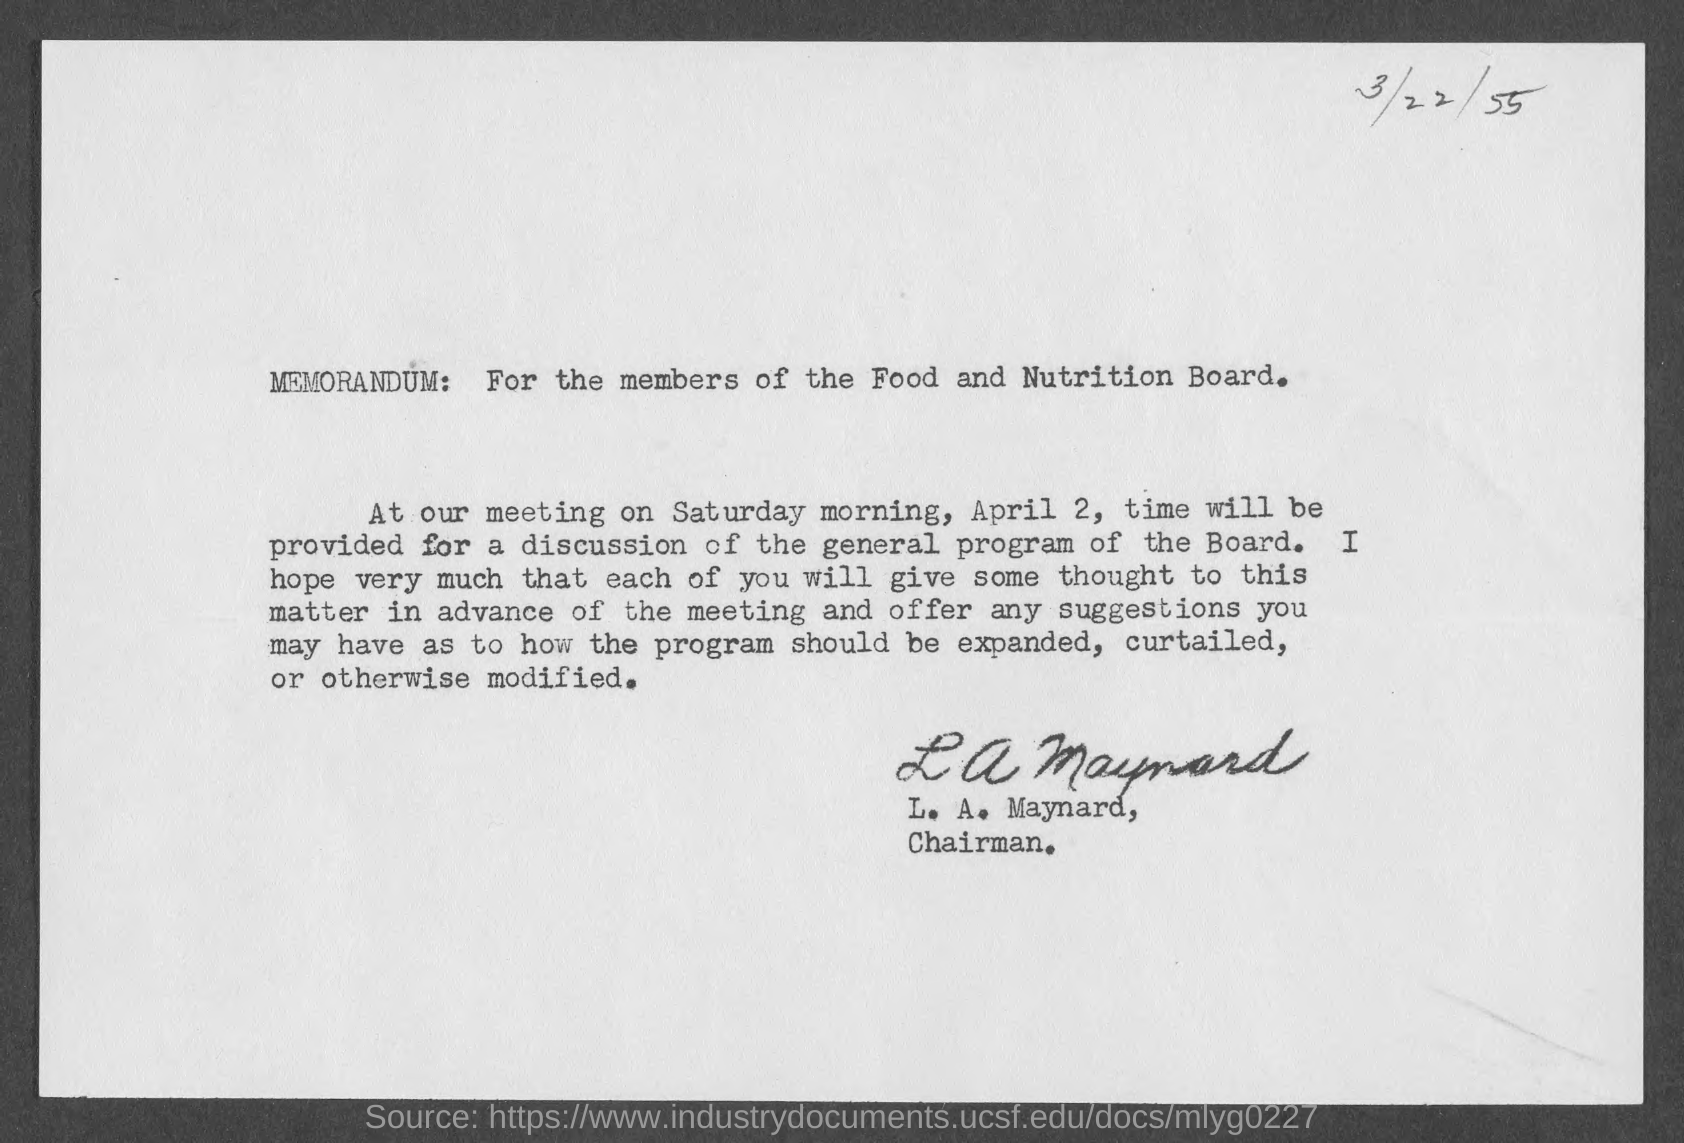When is the document dated?
Keep it short and to the point. 3/22/55. For whom is the Memorandum?
Provide a short and direct response. For the members of the Food and Nutrition Board. Who has signed the document?
Give a very brief answer. L. A. Maynard. 